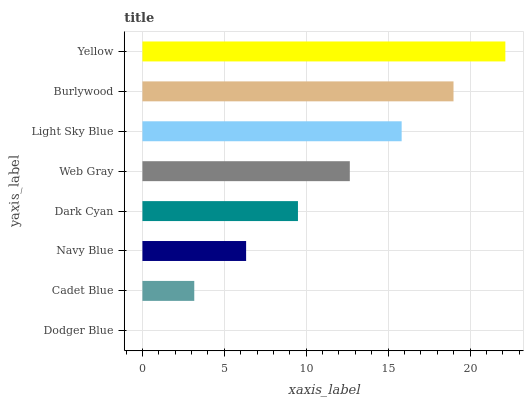Is Dodger Blue the minimum?
Answer yes or no. Yes. Is Yellow the maximum?
Answer yes or no. Yes. Is Cadet Blue the minimum?
Answer yes or no. No. Is Cadet Blue the maximum?
Answer yes or no. No. Is Cadet Blue greater than Dodger Blue?
Answer yes or no. Yes. Is Dodger Blue less than Cadet Blue?
Answer yes or no. Yes. Is Dodger Blue greater than Cadet Blue?
Answer yes or no. No. Is Cadet Blue less than Dodger Blue?
Answer yes or no. No. Is Web Gray the high median?
Answer yes or no. Yes. Is Dark Cyan the low median?
Answer yes or no. Yes. Is Navy Blue the high median?
Answer yes or no. No. Is Navy Blue the low median?
Answer yes or no. No. 